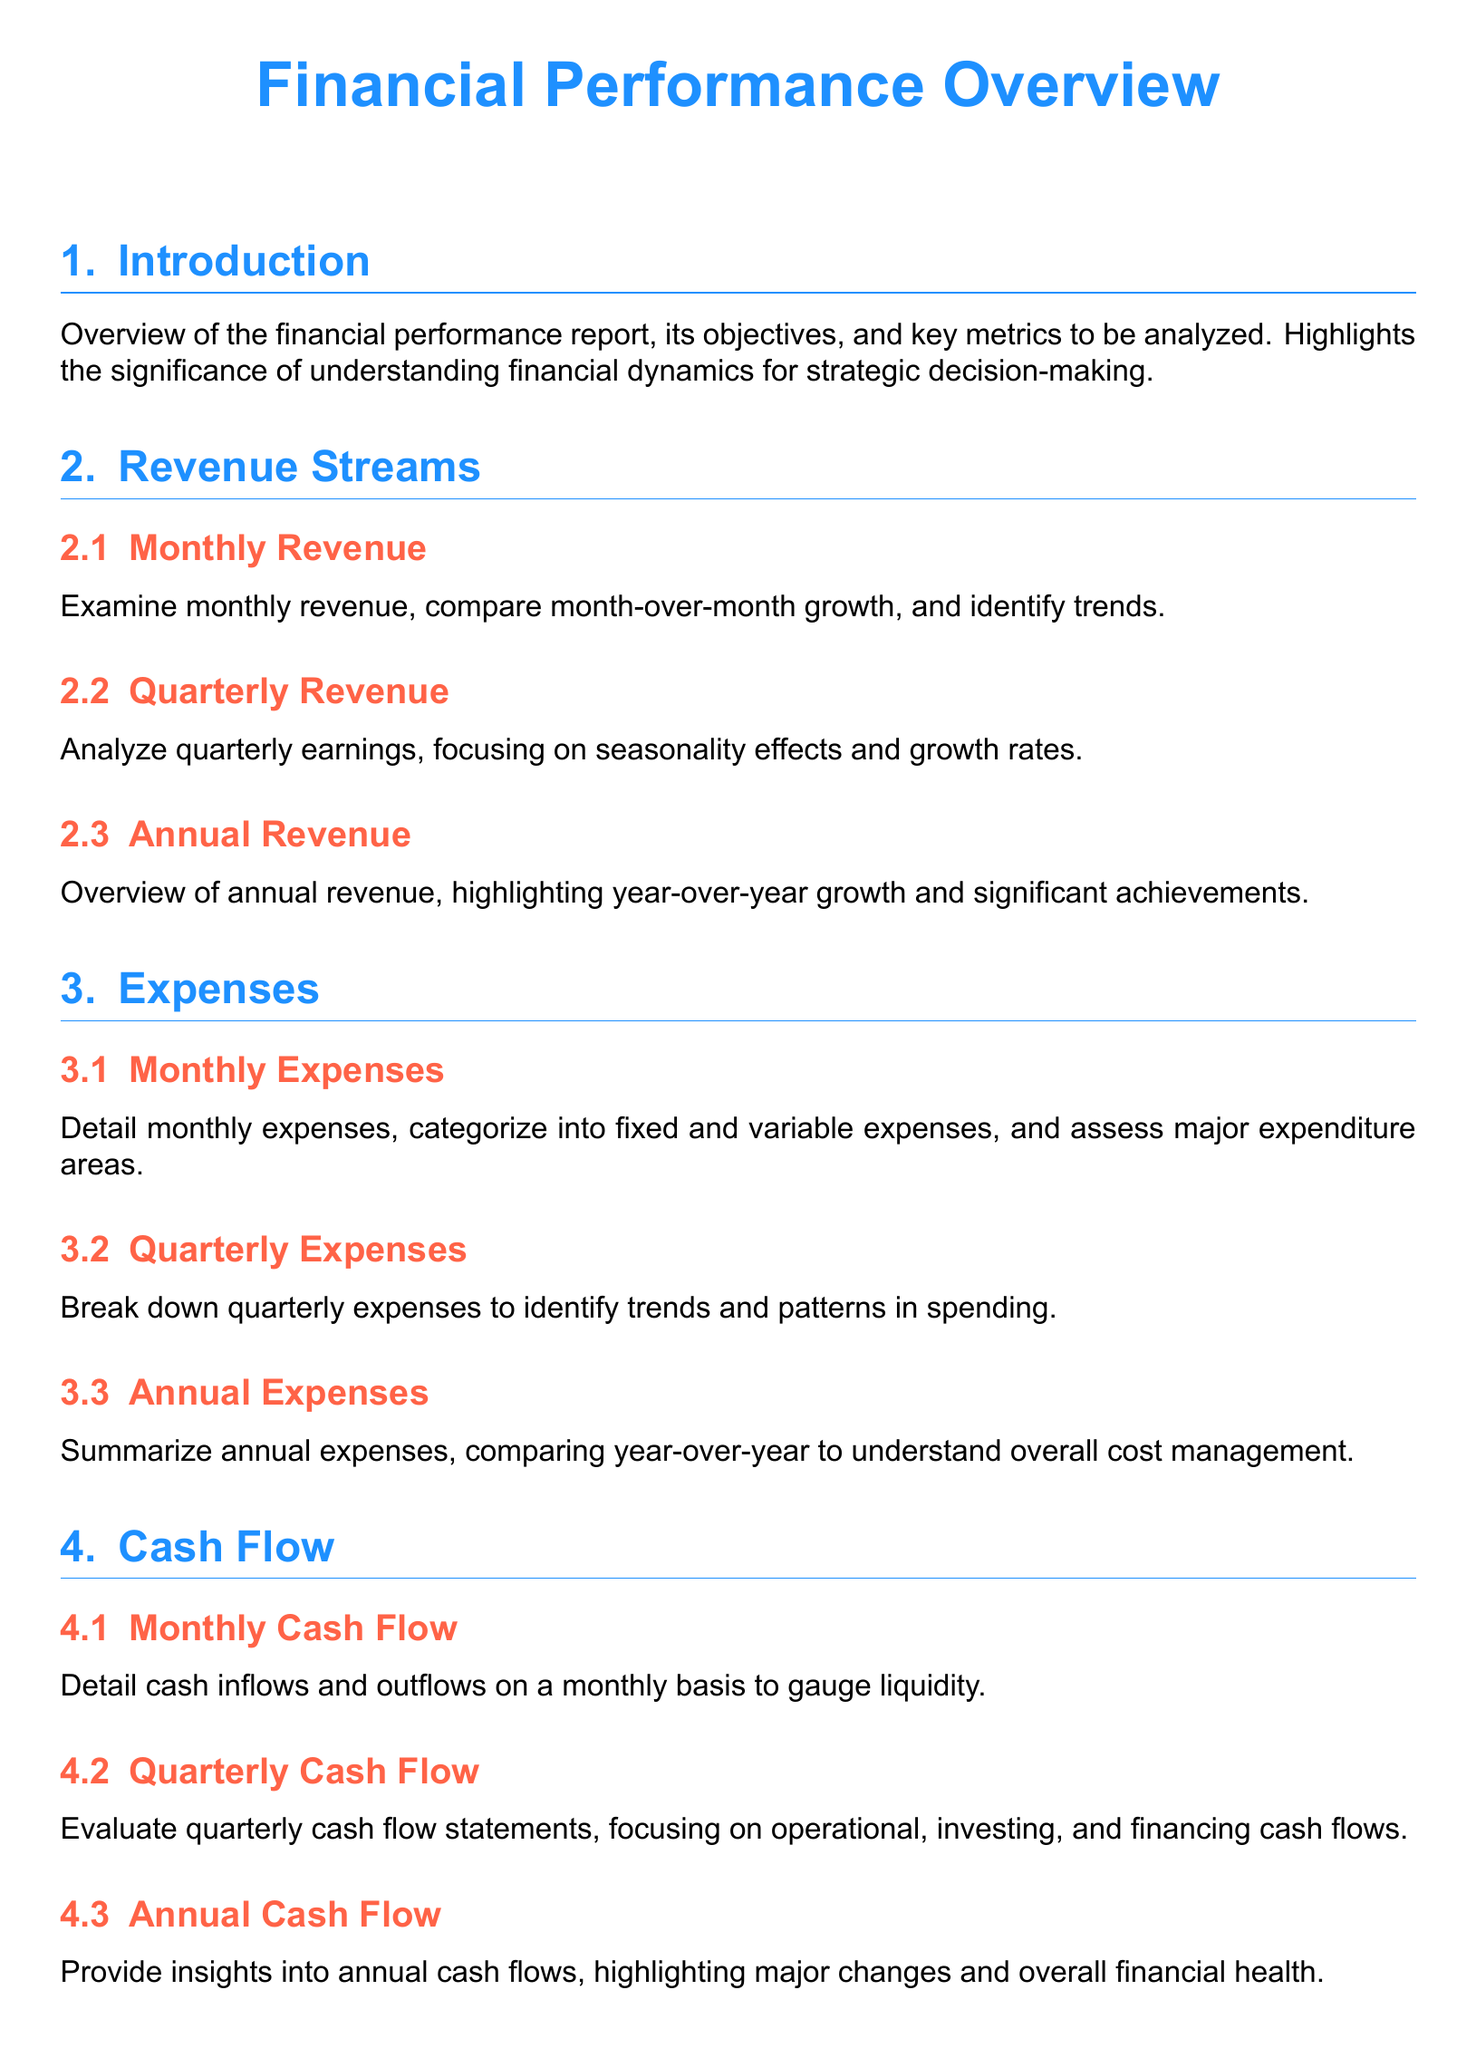what is the focus of the report? The focus of the report is to provide a comprehensive overview of financial performance metrics, including revenue, expenses, cash flow, and profitability.
Answer: financial performance metrics what are the types of revenue analyzed? The types of revenue analyzed include monthly, quarterly, and annual revenue streams.
Answer: monthly, quarterly, annual what does the gross profit margin section compare to? The gross profit margin section compares against industry benchmark comparisons.
Answer: industry benchmark comparisons which categories are used for monthly expenses? Monthly expenses are categorized into fixed and variable expenses.
Answer: fixed and variable expenses what is highlighted in the annual revenue section? The annual revenue section highlights year-over-year growth and significant achievements.
Answer: year-over-year growth and significant achievements what does the cash flow section evaluate? The cash flow section evaluates monthly, quarterly, and annual cash flow statements.
Answer: monthly, quarterly, annual cash flow statements how is the operating profit margin described? The operating profit margin is described in terms of operational efficiency over different periods.
Answer: operational efficiency what key metrics does the introduction emphasize? The introduction emphasizes understanding financial dynamics for strategic decision-making.
Answer: understanding financial dynamics for strategic decision-making what is the return on investment section focused on? The return on investment section is focused on assessing returns generated on investments.
Answer: assessing returns generated on investments 